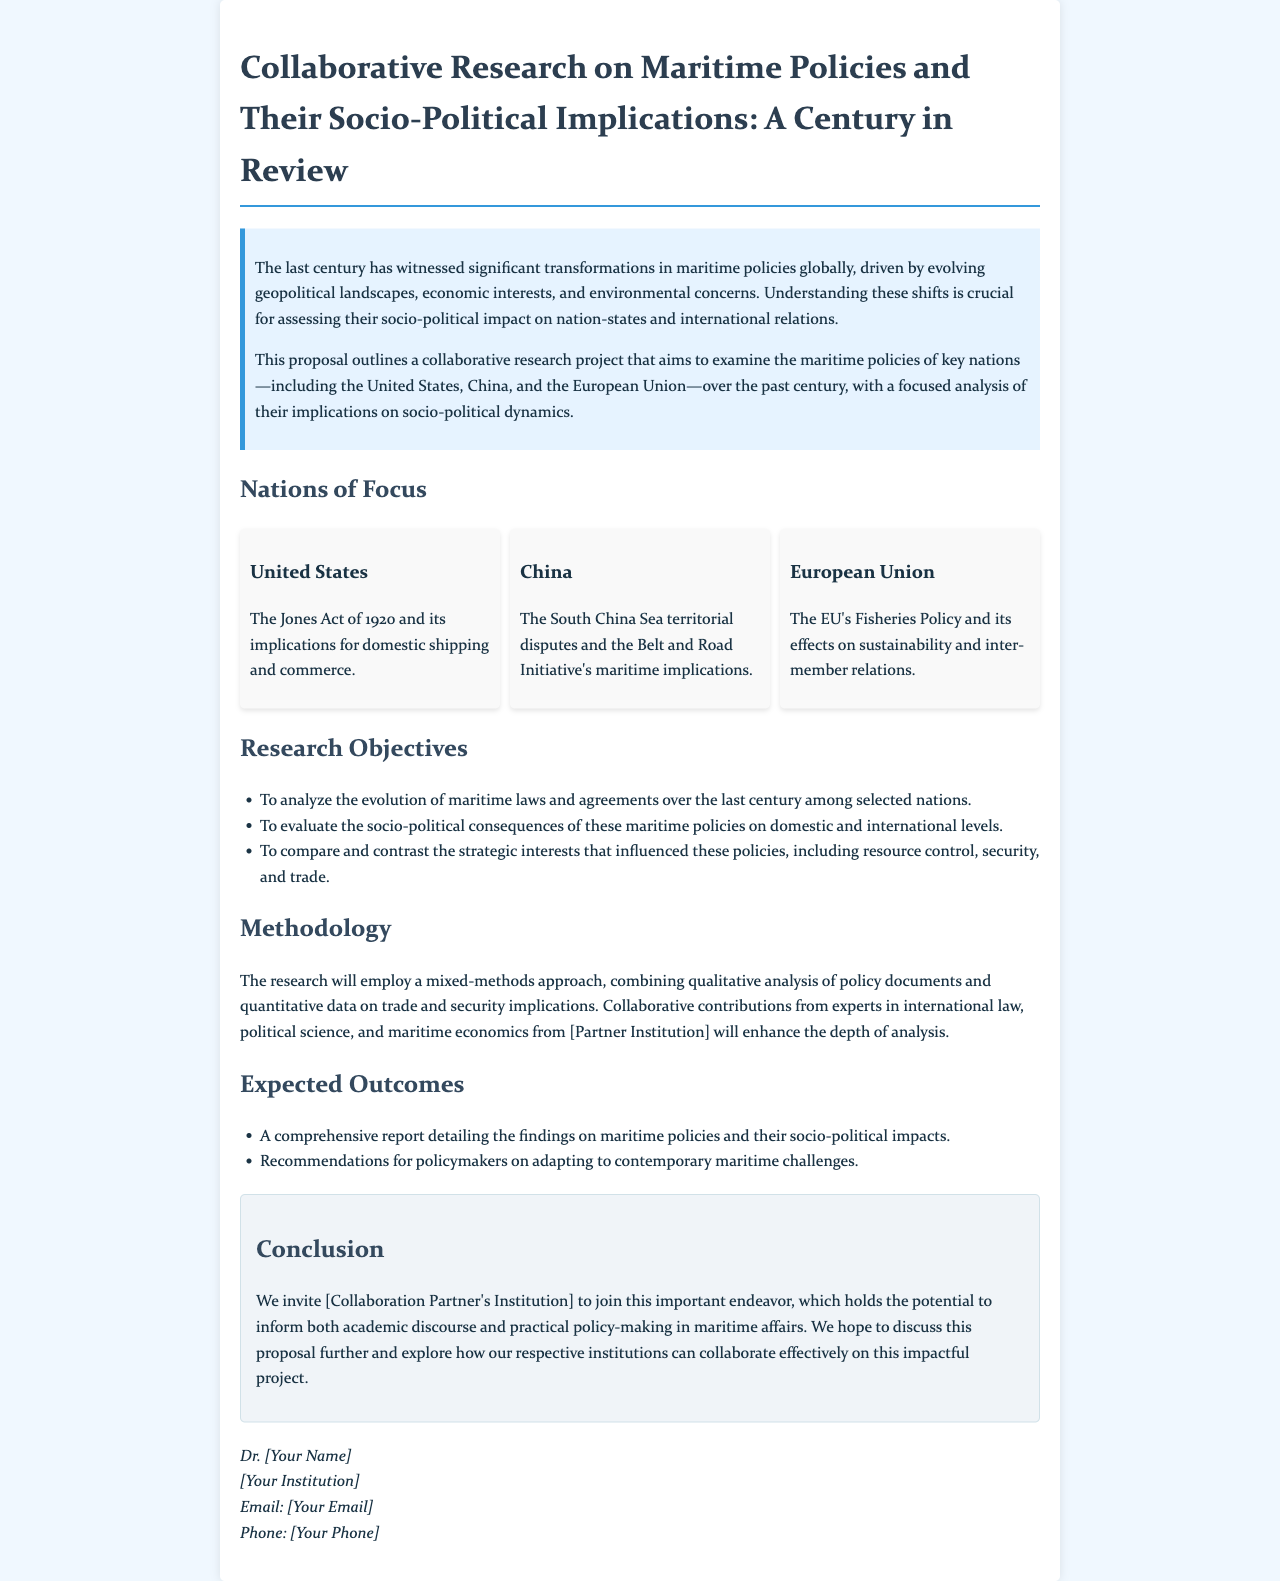What is the title of the proposal letter? The title of the proposal letter is the main heading specified in the document, which outlines the research focus.
Answer: Collaborative Research on Maritime Policies and Their Socio-Political Implications: A Century in Review Which act is associated with the United States' maritime policy? The act is explicitly mentioned in the section focusing on the United States' maritime policy, detailing its significance.
Answer: The Jones Act of 1920 What type of approach will the research employ? The letter describes the methodological approach that will be used in the research project.
Answer: Mixed-methods approach What is one of the expected outcomes of the research? The expected outcomes are specifically outlined in their own section, listing the potential products of the study.
Answer: A comprehensive report detailing the findings Which nation focuses on the South China Sea in its maritime policies? The letter identifies a specific nation and its focus area within the broader context of maritime policies.
Answer: China What are the key themes under research objectives? This requires connecting different research objectives listed in the document to summarize their focus.
Answer: Evolution of maritime laws, socio-political consequences, strategic interests What is the overall purpose of the proposal? The purpose is outlined in the introduction, emphasizing what the research aims to achieve.
Answer: Examine the maritime policies of key nations and their socio-political dynamics What type of institutions are being invited for collaboration? The type of institutions refers to the specific nature of partnerships being sought as mentioned in the conclusion.
Answer: [Collaboration Partner's Institution] 